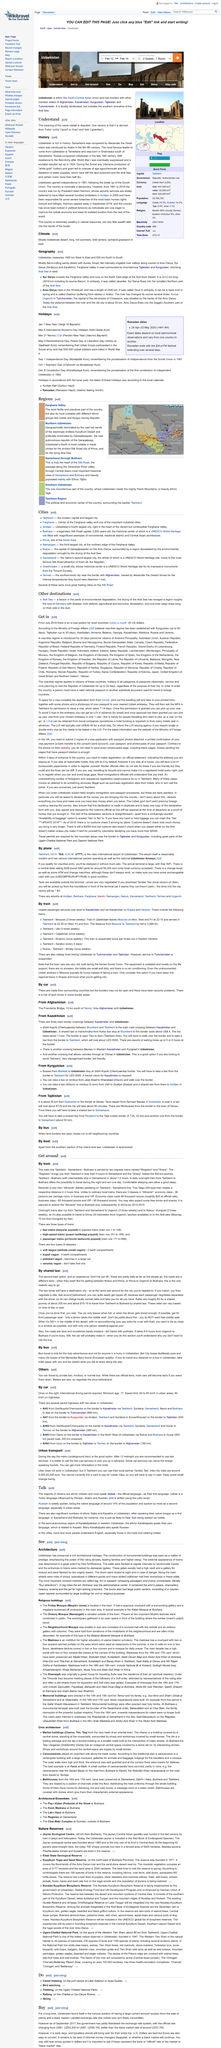Specify some key components in this picture. There are three main border crossings between Kazakhstan and Uzbekistan. The local taxi rates in the United States are approximately US$3 for a shared journey of approximately 200 kilometers and US$10-15 to travel from Tashkent to Bukhara by shared taxi. The minimum age to drive a car in Uzbekistan is seventeen years old. Taxis in the area are generally safe, but the road conditions should be taken into consideration. It is recommended to agree on a fare before getting into a taxi to avoid being overcharged. The doors to the towns were closed at night and in case of danger, and they were closed when it was necessary to do so. 